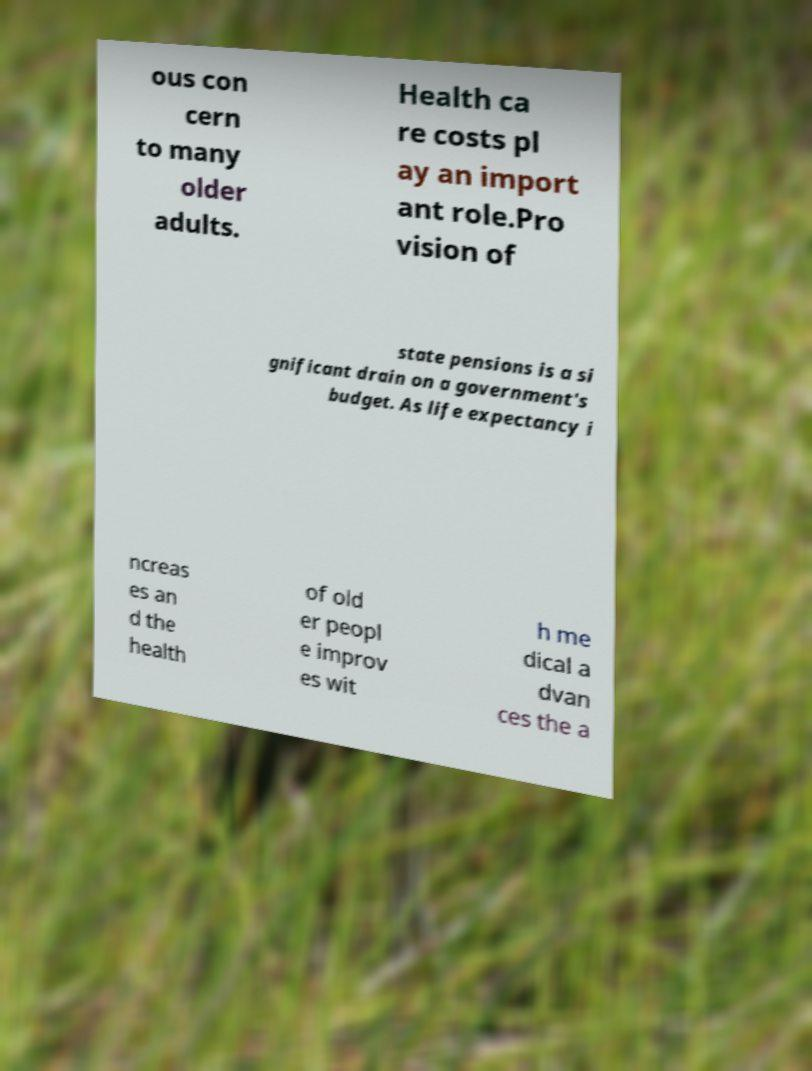There's text embedded in this image that I need extracted. Can you transcribe it verbatim? ous con cern to many older adults. Health ca re costs pl ay an import ant role.Pro vision of state pensions is a si gnificant drain on a government's budget. As life expectancy i ncreas es an d the health of old er peopl e improv es wit h me dical a dvan ces the a 